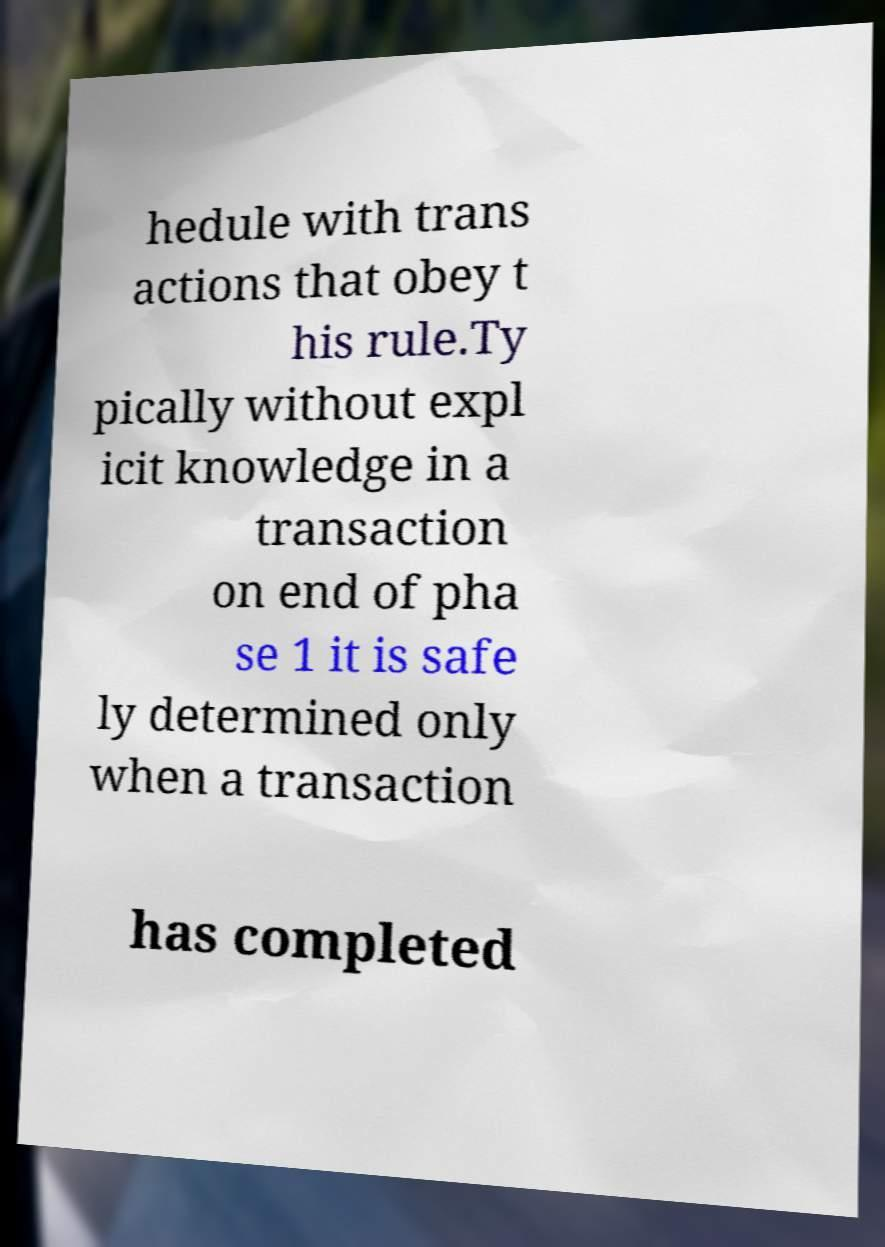Please identify and transcribe the text found in this image. hedule with trans actions that obey t his rule.Ty pically without expl icit knowledge in a transaction on end of pha se 1 it is safe ly determined only when a transaction has completed 